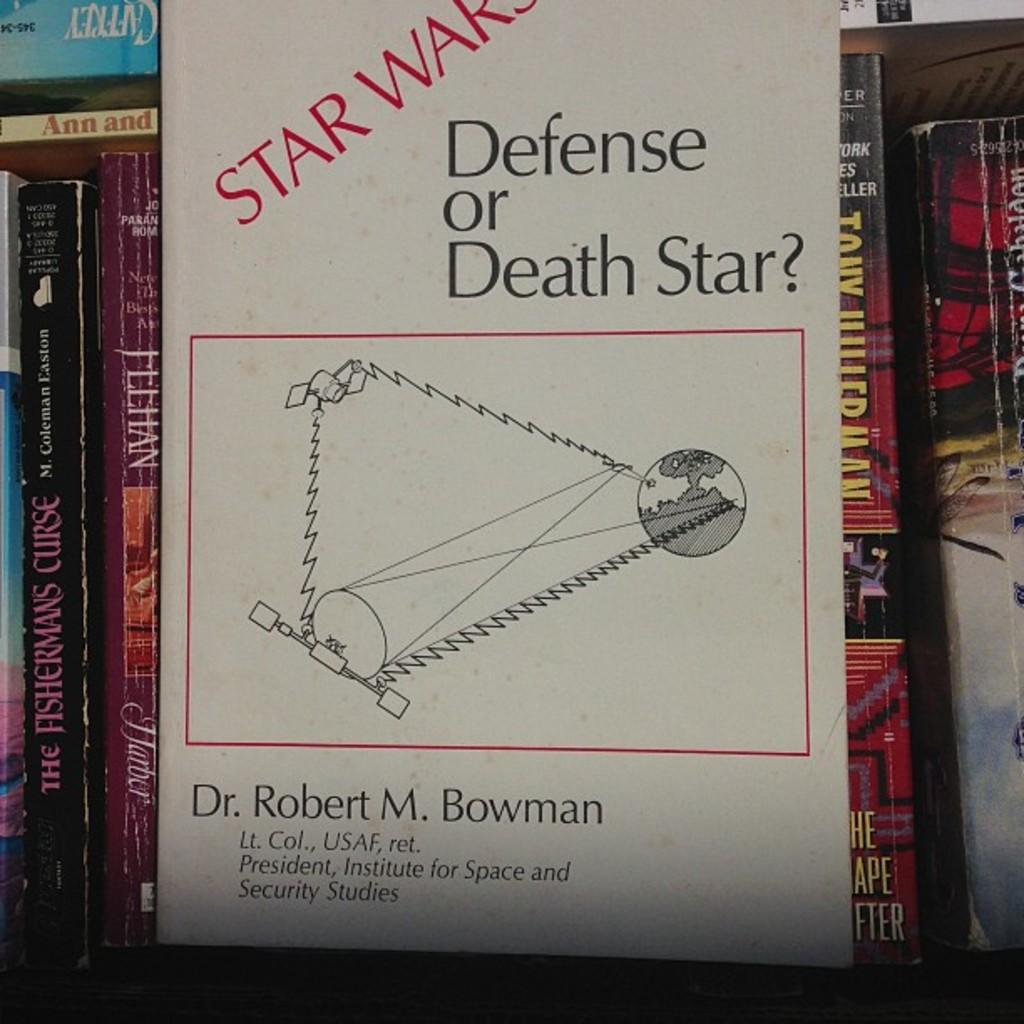Provide a one-sentence caption for the provided image. a book shelf with Star Wars Defense or Death Star on the front. 